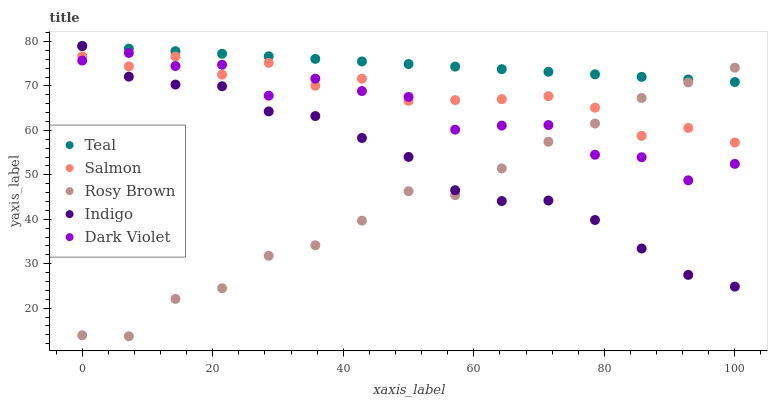Does Rosy Brown have the minimum area under the curve?
Answer yes or no. Yes. Does Teal have the maximum area under the curve?
Answer yes or no. Yes. Does Salmon have the minimum area under the curve?
Answer yes or no. No. Does Salmon have the maximum area under the curve?
Answer yes or no. No. Is Teal the smoothest?
Answer yes or no. Yes. Is Dark Violet the roughest?
Answer yes or no. Yes. Is Rosy Brown the smoothest?
Answer yes or no. No. Is Rosy Brown the roughest?
Answer yes or no. No. Does Rosy Brown have the lowest value?
Answer yes or no. Yes. Does Salmon have the lowest value?
Answer yes or no. No. Does Teal have the highest value?
Answer yes or no. Yes. Does Salmon have the highest value?
Answer yes or no. No. Is Dark Violet less than Teal?
Answer yes or no. Yes. Is Teal greater than Dark Violet?
Answer yes or no. Yes. Does Salmon intersect Dark Violet?
Answer yes or no. Yes. Is Salmon less than Dark Violet?
Answer yes or no. No. Is Salmon greater than Dark Violet?
Answer yes or no. No. Does Dark Violet intersect Teal?
Answer yes or no. No. 